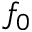<formula> <loc_0><loc_0><loc_500><loc_500>f _ { 0 }</formula> 